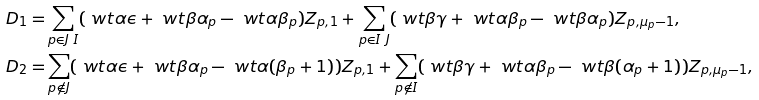<formula> <loc_0><loc_0><loc_500><loc_500>D _ { 1 } = & \sum _ { p \in J \ I } ( \ w t \alpha \epsilon + \ w t \beta \alpha _ { p } - \ w t \alpha \beta _ { p } ) Z _ { p , 1 } + \sum _ { p \in I \ J } ( \ w t \beta \gamma + \ w t \alpha \beta _ { p } - \ w t \beta \alpha _ { p } ) Z _ { p , \mu _ { p } - 1 } , \\ D _ { 2 } = & \sum _ { p \not \in J } ( \ w t \alpha \epsilon + \ w t \beta \alpha _ { p } - \ w t \alpha ( \beta _ { p } + 1 ) ) Z _ { p , 1 } + \sum _ { p \not \in I } ( \ w t \beta \gamma + \ w t \alpha \beta _ { p } - \ w t \beta ( \alpha _ { p } + 1 ) ) Z _ { p , \mu _ { p } - 1 } ,</formula> 